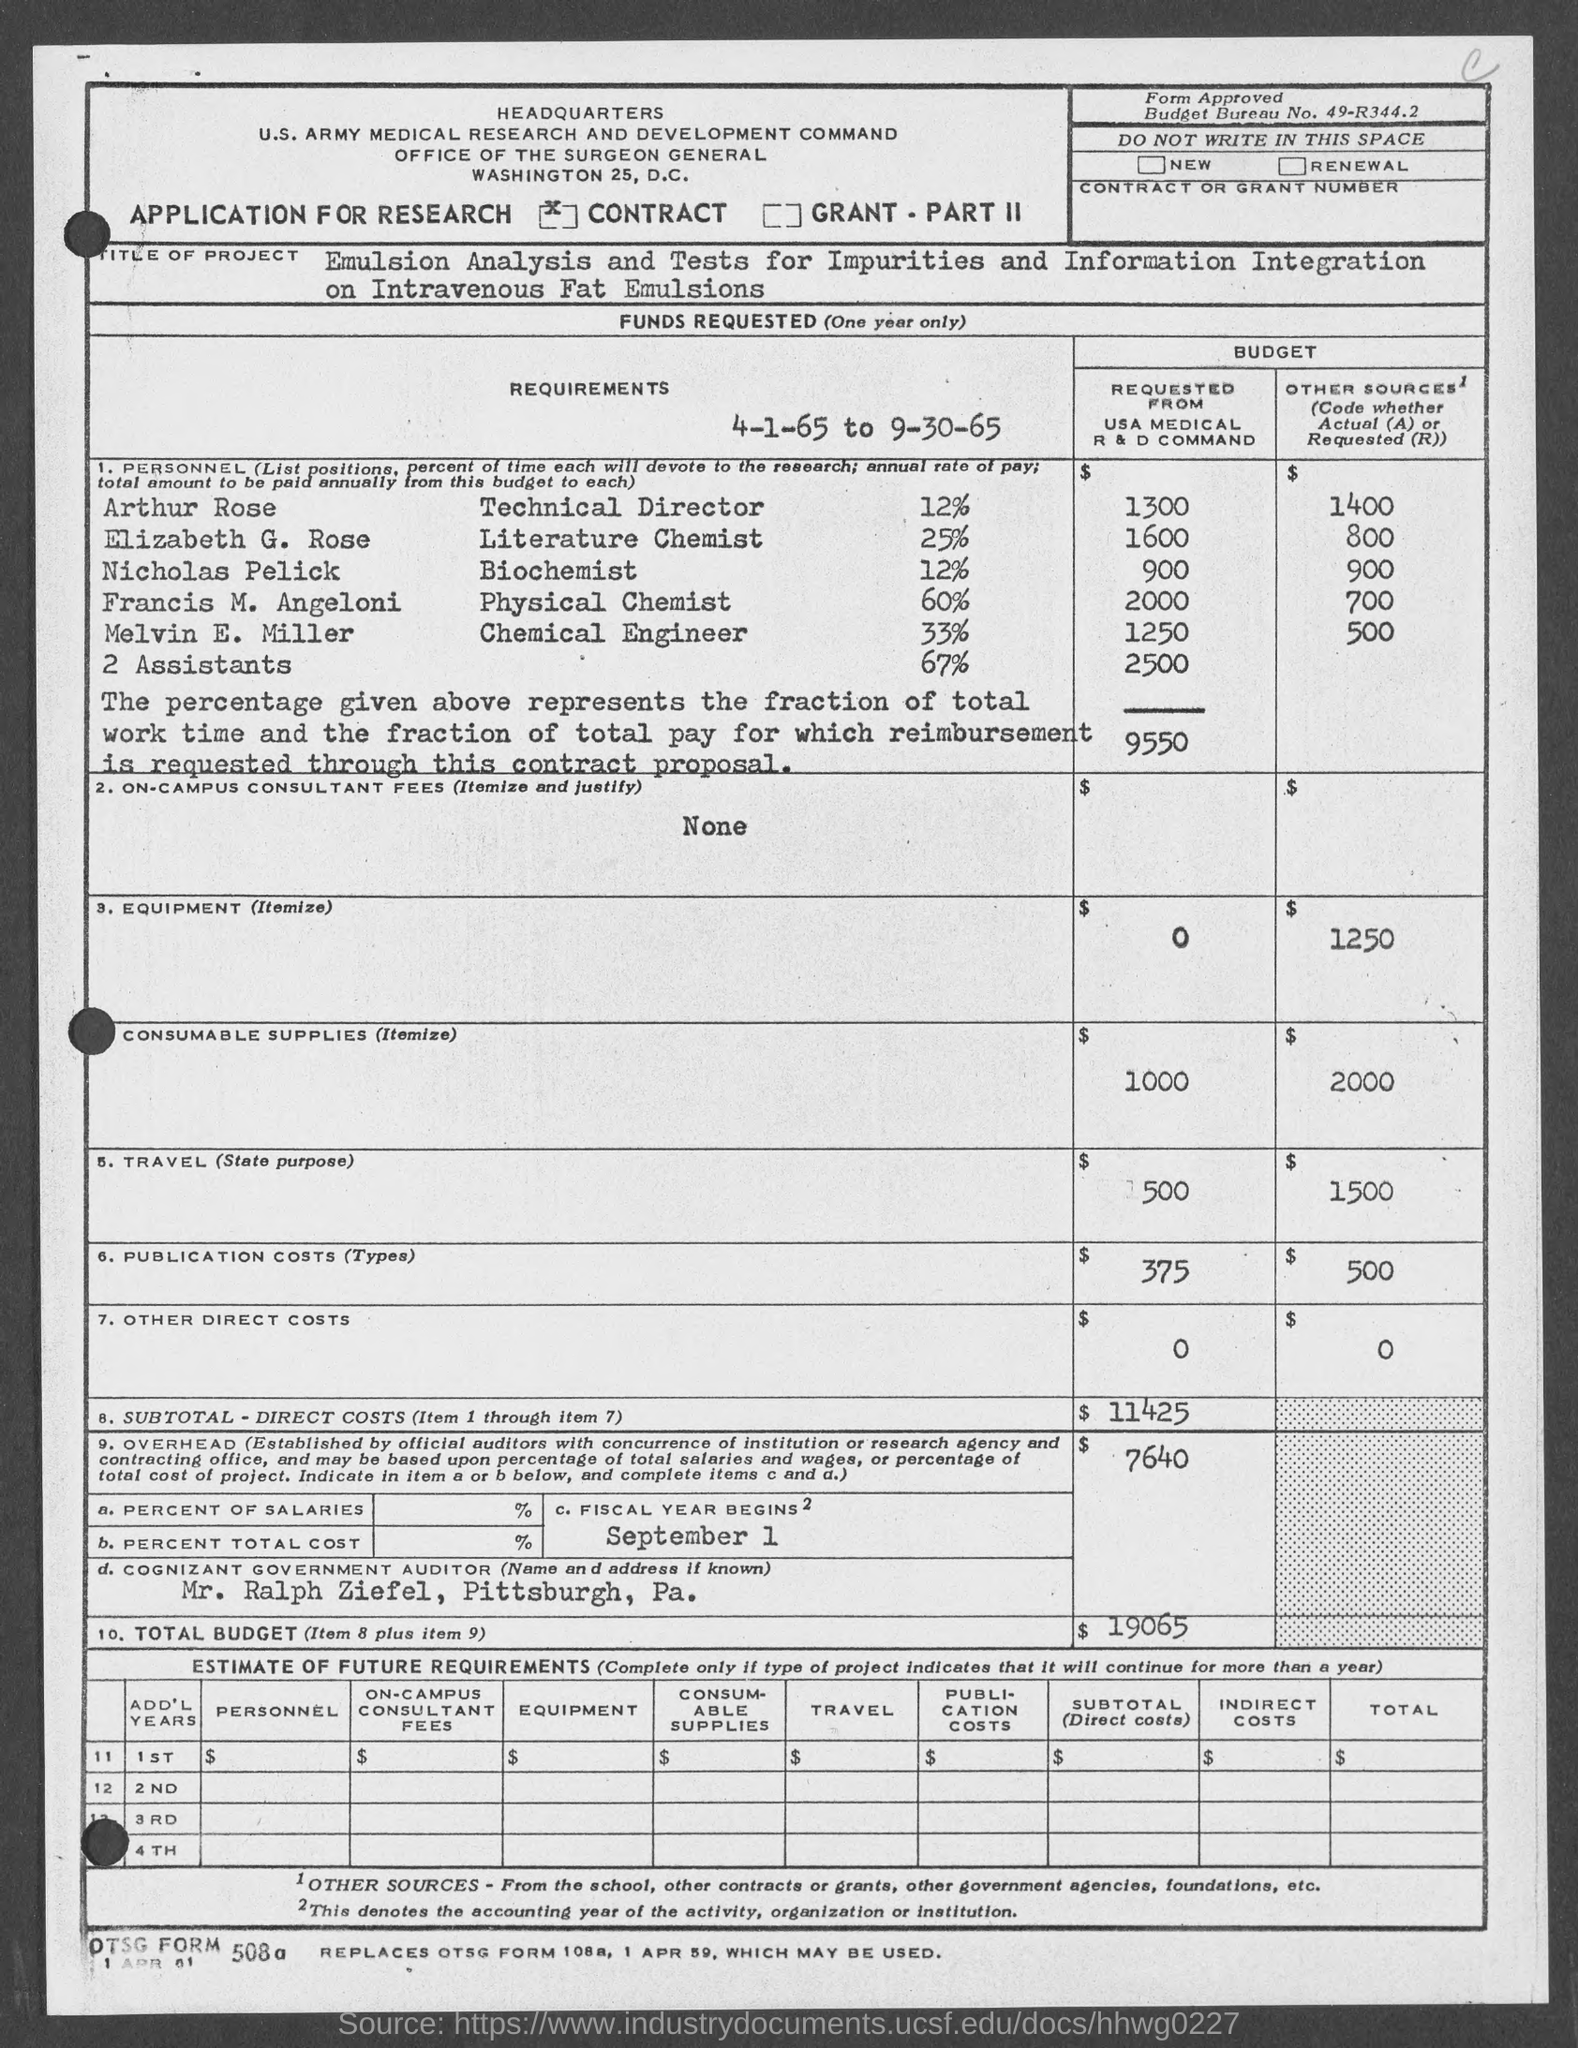What is the budget bureau no.?
Give a very brief answer. 49-R344.2. Who is the cognizant government auditor ?
Keep it short and to the point. Mr. ralph ziefel. 